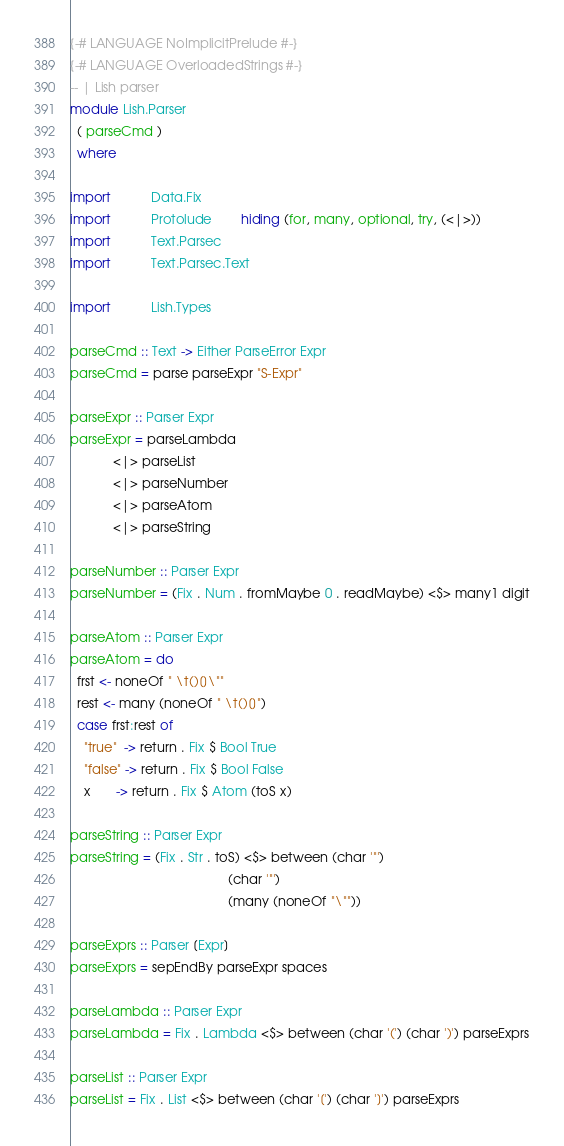<code> <loc_0><loc_0><loc_500><loc_500><_Haskell_>{-# LANGUAGE NoImplicitPrelude #-}
{-# LANGUAGE OverloadedStrings #-}
-- | Lish parser
module Lish.Parser
  ( parseCmd )
  where

import           Data.Fix
import           Protolude        hiding (for, many, optional, try, (<|>))
import           Text.Parsec
import           Text.Parsec.Text

import           Lish.Types

parseCmd :: Text -> Either ParseError Expr
parseCmd = parse parseExpr "S-Expr"

parseExpr :: Parser Expr
parseExpr = parseLambda
            <|> parseList
            <|> parseNumber
            <|> parseAtom
            <|> parseString

parseNumber :: Parser Expr
parseNumber = (Fix . Num . fromMaybe 0 . readMaybe) <$> many1 digit

parseAtom :: Parser Expr
parseAtom = do
  frst <- noneOf " \t()[]\""
  rest <- many (noneOf " \t()[]")
  case frst:rest of
    "true"  -> return . Fix $ Bool True
    "false" -> return . Fix $ Bool False
    x       -> return . Fix $ Atom (toS x)

parseString :: Parser Expr
parseString = (Fix . Str . toS) <$> between (char '"')
                                            (char '"')
                                            (many (noneOf "\""))

parseExprs :: Parser [Expr]
parseExprs = sepEndBy parseExpr spaces

parseLambda :: Parser Expr
parseLambda = Fix . Lambda <$> between (char '(') (char ')') parseExprs

parseList :: Parser Expr
parseList = Fix . List <$> between (char '[') (char ']') parseExprs
</code> 